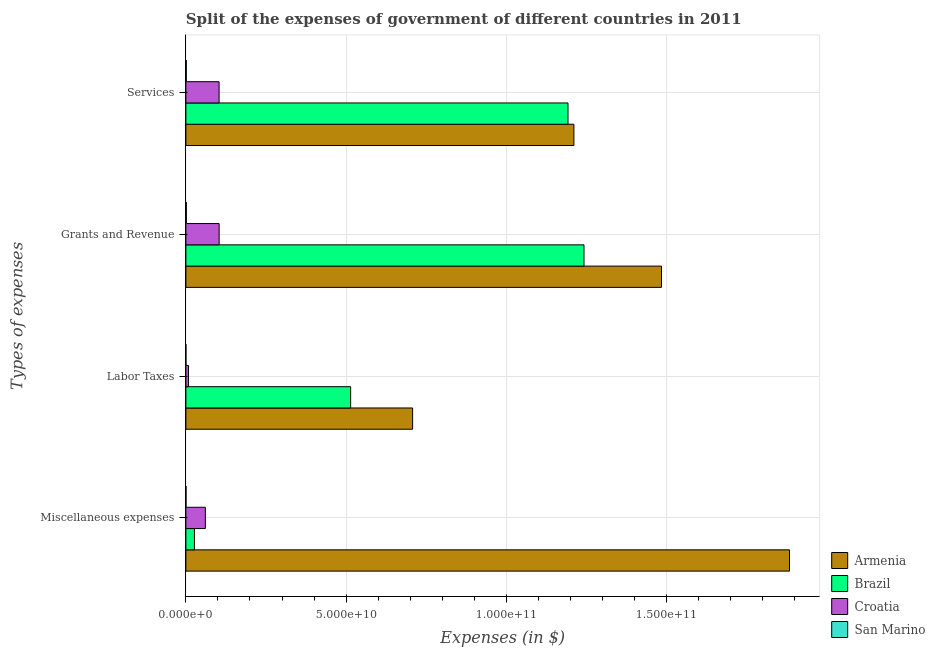Are the number of bars per tick equal to the number of legend labels?
Give a very brief answer. Yes. How many bars are there on the 4th tick from the top?
Your answer should be very brief. 4. What is the label of the 4th group of bars from the top?
Make the answer very short. Miscellaneous expenses. What is the amount spent on grants and revenue in Brazil?
Keep it short and to the point. 1.24e+11. Across all countries, what is the maximum amount spent on labor taxes?
Keep it short and to the point. 7.07e+1. Across all countries, what is the minimum amount spent on grants and revenue?
Offer a very short reply. 1.51e+08. In which country was the amount spent on grants and revenue maximum?
Make the answer very short. Armenia. In which country was the amount spent on labor taxes minimum?
Your answer should be compact. San Marino. What is the total amount spent on services in the graph?
Provide a succinct answer. 2.51e+11. What is the difference between the amount spent on services in Croatia and that in Armenia?
Your answer should be very brief. -1.11e+11. What is the difference between the amount spent on services in San Marino and the amount spent on labor taxes in Armenia?
Offer a terse response. -7.06e+1. What is the average amount spent on grants and revenue per country?
Provide a short and direct response. 7.08e+1. What is the difference between the amount spent on miscellaneous expenses and amount spent on labor taxes in Armenia?
Your answer should be compact. 1.18e+11. In how many countries, is the amount spent on labor taxes greater than 110000000000 $?
Provide a succinct answer. 0. What is the ratio of the amount spent on services in Brazil to that in Croatia?
Your response must be concise. 11.5. Is the difference between the amount spent on services in Armenia and Brazil greater than the difference between the amount spent on miscellaneous expenses in Armenia and Brazil?
Provide a succinct answer. No. What is the difference between the highest and the second highest amount spent on grants and revenue?
Your response must be concise. 2.42e+1. What is the difference between the highest and the lowest amount spent on labor taxes?
Make the answer very short. 7.07e+1. Is the sum of the amount spent on miscellaneous expenses in Brazil and San Marino greater than the maximum amount spent on labor taxes across all countries?
Provide a short and direct response. No. Is it the case that in every country, the sum of the amount spent on labor taxes and amount spent on miscellaneous expenses is greater than the sum of amount spent on grants and revenue and amount spent on services?
Provide a succinct answer. No. What does the 1st bar from the top in Grants and Revenue represents?
Your answer should be very brief. San Marino. What does the 1st bar from the bottom in Services represents?
Ensure brevity in your answer.  Armenia. How many bars are there?
Offer a terse response. 16. What is the difference between two consecutive major ticks on the X-axis?
Offer a terse response. 5.00e+1. Are the values on the major ticks of X-axis written in scientific E-notation?
Offer a terse response. Yes. Does the graph contain grids?
Your response must be concise. Yes. How many legend labels are there?
Offer a very short reply. 4. What is the title of the graph?
Provide a succinct answer. Split of the expenses of government of different countries in 2011. What is the label or title of the X-axis?
Give a very brief answer. Expenses (in $). What is the label or title of the Y-axis?
Offer a very short reply. Types of expenses. What is the Expenses (in $) of Armenia in Miscellaneous expenses?
Provide a succinct answer. 1.88e+11. What is the Expenses (in $) of Brazil in Miscellaneous expenses?
Make the answer very short. 2.67e+09. What is the Expenses (in $) in Croatia in Miscellaneous expenses?
Offer a terse response. 6.08e+09. What is the Expenses (in $) in San Marino in Miscellaneous expenses?
Your answer should be very brief. 3.76e+07. What is the Expenses (in $) in Armenia in Labor Taxes?
Ensure brevity in your answer.  7.07e+1. What is the Expenses (in $) of Brazil in Labor Taxes?
Your answer should be compact. 5.14e+1. What is the Expenses (in $) of Croatia in Labor Taxes?
Your response must be concise. 8.16e+08. What is the Expenses (in $) of San Marino in Labor Taxes?
Give a very brief answer. 1.45e+07. What is the Expenses (in $) in Armenia in Grants and Revenue?
Offer a terse response. 1.48e+11. What is the Expenses (in $) of Brazil in Grants and Revenue?
Your answer should be very brief. 1.24e+11. What is the Expenses (in $) of Croatia in Grants and Revenue?
Offer a terse response. 1.04e+1. What is the Expenses (in $) of San Marino in Grants and Revenue?
Keep it short and to the point. 1.51e+08. What is the Expenses (in $) in Armenia in Services?
Offer a very short reply. 1.21e+11. What is the Expenses (in $) in Brazil in Services?
Your answer should be very brief. 1.19e+11. What is the Expenses (in $) in Croatia in Services?
Ensure brevity in your answer.  1.04e+1. What is the Expenses (in $) of San Marino in Services?
Provide a short and direct response. 1.39e+08. Across all Types of expenses, what is the maximum Expenses (in $) in Armenia?
Ensure brevity in your answer.  1.88e+11. Across all Types of expenses, what is the maximum Expenses (in $) in Brazil?
Provide a short and direct response. 1.24e+11. Across all Types of expenses, what is the maximum Expenses (in $) of Croatia?
Provide a short and direct response. 1.04e+1. Across all Types of expenses, what is the maximum Expenses (in $) of San Marino?
Your answer should be very brief. 1.51e+08. Across all Types of expenses, what is the minimum Expenses (in $) in Armenia?
Keep it short and to the point. 7.07e+1. Across all Types of expenses, what is the minimum Expenses (in $) of Brazil?
Provide a short and direct response. 2.67e+09. Across all Types of expenses, what is the minimum Expenses (in $) in Croatia?
Keep it short and to the point. 8.16e+08. Across all Types of expenses, what is the minimum Expenses (in $) of San Marino?
Ensure brevity in your answer.  1.45e+07. What is the total Expenses (in $) of Armenia in the graph?
Ensure brevity in your answer.  5.28e+11. What is the total Expenses (in $) in Brazil in the graph?
Provide a succinct answer. 2.97e+11. What is the total Expenses (in $) in Croatia in the graph?
Provide a short and direct response. 2.76e+1. What is the total Expenses (in $) in San Marino in the graph?
Provide a short and direct response. 3.43e+08. What is the difference between the Expenses (in $) in Armenia in Miscellaneous expenses and that in Labor Taxes?
Your answer should be compact. 1.18e+11. What is the difference between the Expenses (in $) of Brazil in Miscellaneous expenses and that in Labor Taxes?
Keep it short and to the point. -4.87e+1. What is the difference between the Expenses (in $) of Croatia in Miscellaneous expenses and that in Labor Taxes?
Your answer should be compact. 5.26e+09. What is the difference between the Expenses (in $) in San Marino in Miscellaneous expenses and that in Labor Taxes?
Make the answer very short. 2.31e+07. What is the difference between the Expenses (in $) in Armenia in Miscellaneous expenses and that in Grants and Revenue?
Give a very brief answer. 3.99e+1. What is the difference between the Expenses (in $) in Brazil in Miscellaneous expenses and that in Grants and Revenue?
Give a very brief answer. -1.22e+11. What is the difference between the Expenses (in $) of Croatia in Miscellaneous expenses and that in Grants and Revenue?
Offer a terse response. -4.30e+09. What is the difference between the Expenses (in $) in San Marino in Miscellaneous expenses and that in Grants and Revenue?
Your response must be concise. -1.14e+08. What is the difference between the Expenses (in $) of Armenia in Miscellaneous expenses and that in Services?
Offer a terse response. 6.73e+1. What is the difference between the Expenses (in $) in Brazil in Miscellaneous expenses and that in Services?
Offer a very short reply. -1.17e+11. What is the difference between the Expenses (in $) in Croatia in Miscellaneous expenses and that in Services?
Provide a short and direct response. -4.29e+09. What is the difference between the Expenses (in $) of San Marino in Miscellaneous expenses and that in Services?
Ensure brevity in your answer.  -1.02e+08. What is the difference between the Expenses (in $) of Armenia in Labor Taxes and that in Grants and Revenue?
Offer a terse response. -7.76e+1. What is the difference between the Expenses (in $) of Brazil in Labor Taxes and that in Grants and Revenue?
Your answer should be compact. -7.28e+1. What is the difference between the Expenses (in $) of Croatia in Labor Taxes and that in Grants and Revenue?
Your answer should be very brief. -9.56e+09. What is the difference between the Expenses (in $) of San Marino in Labor Taxes and that in Grants and Revenue?
Your answer should be compact. -1.37e+08. What is the difference between the Expenses (in $) of Armenia in Labor Taxes and that in Services?
Your answer should be very brief. -5.03e+1. What is the difference between the Expenses (in $) of Brazil in Labor Taxes and that in Services?
Give a very brief answer. -6.78e+1. What is the difference between the Expenses (in $) in Croatia in Labor Taxes and that in Services?
Your response must be concise. -9.55e+09. What is the difference between the Expenses (in $) in San Marino in Labor Taxes and that in Services?
Offer a terse response. -1.25e+08. What is the difference between the Expenses (in $) of Armenia in Grants and Revenue and that in Services?
Keep it short and to the point. 2.73e+1. What is the difference between the Expenses (in $) of Brazil in Grants and Revenue and that in Services?
Offer a terse response. 4.99e+09. What is the difference between the Expenses (in $) in Croatia in Grants and Revenue and that in Services?
Give a very brief answer. 1.51e+07. What is the difference between the Expenses (in $) of San Marino in Grants and Revenue and that in Services?
Your answer should be compact. 1.18e+07. What is the difference between the Expenses (in $) in Armenia in Miscellaneous expenses and the Expenses (in $) in Brazil in Labor Taxes?
Your response must be concise. 1.37e+11. What is the difference between the Expenses (in $) of Armenia in Miscellaneous expenses and the Expenses (in $) of Croatia in Labor Taxes?
Offer a very short reply. 1.87e+11. What is the difference between the Expenses (in $) of Armenia in Miscellaneous expenses and the Expenses (in $) of San Marino in Labor Taxes?
Your answer should be compact. 1.88e+11. What is the difference between the Expenses (in $) in Brazil in Miscellaneous expenses and the Expenses (in $) in Croatia in Labor Taxes?
Give a very brief answer. 1.86e+09. What is the difference between the Expenses (in $) of Brazil in Miscellaneous expenses and the Expenses (in $) of San Marino in Labor Taxes?
Provide a succinct answer. 2.66e+09. What is the difference between the Expenses (in $) in Croatia in Miscellaneous expenses and the Expenses (in $) in San Marino in Labor Taxes?
Provide a short and direct response. 6.06e+09. What is the difference between the Expenses (in $) of Armenia in Miscellaneous expenses and the Expenses (in $) of Brazil in Grants and Revenue?
Offer a terse response. 6.41e+1. What is the difference between the Expenses (in $) of Armenia in Miscellaneous expenses and the Expenses (in $) of Croatia in Grants and Revenue?
Your answer should be very brief. 1.78e+11. What is the difference between the Expenses (in $) in Armenia in Miscellaneous expenses and the Expenses (in $) in San Marino in Grants and Revenue?
Your answer should be very brief. 1.88e+11. What is the difference between the Expenses (in $) of Brazil in Miscellaneous expenses and the Expenses (in $) of Croatia in Grants and Revenue?
Provide a succinct answer. -7.71e+09. What is the difference between the Expenses (in $) of Brazil in Miscellaneous expenses and the Expenses (in $) of San Marino in Grants and Revenue?
Offer a terse response. 2.52e+09. What is the difference between the Expenses (in $) in Croatia in Miscellaneous expenses and the Expenses (in $) in San Marino in Grants and Revenue?
Your response must be concise. 5.93e+09. What is the difference between the Expenses (in $) in Armenia in Miscellaneous expenses and the Expenses (in $) in Brazil in Services?
Your response must be concise. 6.91e+1. What is the difference between the Expenses (in $) of Armenia in Miscellaneous expenses and the Expenses (in $) of Croatia in Services?
Make the answer very short. 1.78e+11. What is the difference between the Expenses (in $) of Armenia in Miscellaneous expenses and the Expenses (in $) of San Marino in Services?
Offer a terse response. 1.88e+11. What is the difference between the Expenses (in $) in Brazil in Miscellaneous expenses and the Expenses (in $) in Croatia in Services?
Your answer should be very brief. -7.69e+09. What is the difference between the Expenses (in $) in Brazil in Miscellaneous expenses and the Expenses (in $) in San Marino in Services?
Provide a short and direct response. 2.53e+09. What is the difference between the Expenses (in $) of Croatia in Miscellaneous expenses and the Expenses (in $) of San Marino in Services?
Make the answer very short. 5.94e+09. What is the difference between the Expenses (in $) of Armenia in Labor Taxes and the Expenses (in $) of Brazil in Grants and Revenue?
Your answer should be compact. -5.35e+1. What is the difference between the Expenses (in $) in Armenia in Labor Taxes and the Expenses (in $) in Croatia in Grants and Revenue?
Your answer should be compact. 6.04e+1. What is the difference between the Expenses (in $) in Armenia in Labor Taxes and the Expenses (in $) in San Marino in Grants and Revenue?
Make the answer very short. 7.06e+1. What is the difference between the Expenses (in $) in Brazil in Labor Taxes and the Expenses (in $) in Croatia in Grants and Revenue?
Your answer should be very brief. 4.10e+1. What is the difference between the Expenses (in $) of Brazil in Labor Taxes and the Expenses (in $) of San Marino in Grants and Revenue?
Provide a succinct answer. 5.12e+1. What is the difference between the Expenses (in $) of Croatia in Labor Taxes and the Expenses (in $) of San Marino in Grants and Revenue?
Make the answer very short. 6.65e+08. What is the difference between the Expenses (in $) in Armenia in Labor Taxes and the Expenses (in $) in Brazil in Services?
Offer a very short reply. -4.85e+1. What is the difference between the Expenses (in $) of Armenia in Labor Taxes and the Expenses (in $) of Croatia in Services?
Give a very brief answer. 6.04e+1. What is the difference between the Expenses (in $) in Armenia in Labor Taxes and the Expenses (in $) in San Marino in Services?
Provide a succinct answer. 7.06e+1. What is the difference between the Expenses (in $) in Brazil in Labor Taxes and the Expenses (in $) in Croatia in Services?
Give a very brief answer. 4.10e+1. What is the difference between the Expenses (in $) of Brazil in Labor Taxes and the Expenses (in $) of San Marino in Services?
Keep it short and to the point. 5.13e+1. What is the difference between the Expenses (in $) of Croatia in Labor Taxes and the Expenses (in $) of San Marino in Services?
Your response must be concise. 6.77e+08. What is the difference between the Expenses (in $) in Armenia in Grants and Revenue and the Expenses (in $) in Brazil in Services?
Your answer should be compact. 2.92e+1. What is the difference between the Expenses (in $) of Armenia in Grants and Revenue and the Expenses (in $) of Croatia in Services?
Your response must be concise. 1.38e+11. What is the difference between the Expenses (in $) in Armenia in Grants and Revenue and the Expenses (in $) in San Marino in Services?
Offer a terse response. 1.48e+11. What is the difference between the Expenses (in $) in Brazil in Grants and Revenue and the Expenses (in $) in Croatia in Services?
Make the answer very short. 1.14e+11. What is the difference between the Expenses (in $) of Brazil in Grants and Revenue and the Expenses (in $) of San Marino in Services?
Your response must be concise. 1.24e+11. What is the difference between the Expenses (in $) in Croatia in Grants and Revenue and the Expenses (in $) in San Marino in Services?
Your answer should be very brief. 1.02e+1. What is the average Expenses (in $) of Armenia per Types of expenses?
Ensure brevity in your answer.  1.32e+11. What is the average Expenses (in $) in Brazil per Types of expenses?
Make the answer very short. 7.44e+1. What is the average Expenses (in $) in Croatia per Types of expenses?
Make the answer very short. 6.91e+09. What is the average Expenses (in $) of San Marino per Types of expenses?
Offer a very short reply. 8.57e+07. What is the difference between the Expenses (in $) in Armenia and Expenses (in $) in Brazil in Miscellaneous expenses?
Your response must be concise. 1.86e+11. What is the difference between the Expenses (in $) of Armenia and Expenses (in $) of Croatia in Miscellaneous expenses?
Keep it short and to the point. 1.82e+11. What is the difference between the Expenses (in $) in Armenia and Expenses (in $) in San Marino in Miscellaneous expenses?
Offer a very short reply. 1.88e+11. What is the difference between the Expenses (in $) in Brazil and Expenses (in $) in Croatia in Miscellaneous expenses?
Offer a very short reply. -3.40e+09. What is the difference between the Expenses (in $) of Brazil and Expenses (in $) of San Marino in Miscellaneous expenses?
Give a very brief answer. 2.64e+09. What is the difference between the Expenses (in $) of Croatia and Expenses (in $) of San Marino in Miscellaneous expenses?
Your response must be concise. 6.04e+09. What is the difference between the Expenses (in $) in Armenia and Expenses (in $) in Brazil in Labor Taxes?
Your response must be concise. 1.93e+1. What is the difference between the Expenses (in $) of Armenia and Expenses (in $) of Croatia in Labor Taxes?
Make the answer very short. 6.99e+1. What is the difference between the Expenses (in $) in Armenia and Expenses (in $) in San Marino in Labor Taxes?
Offer a very short reply. 7.07e+1. What is the difference between the Expenses (in $) of Brazil and Expenses (in $) of Croatia in Labor Taxes?
Your answer should be compact. 5.06e+1. What is the difference between the Expenses (in $) of Brazil and Expenses (in $) of San Marino in Labor Taxes?
Make the answer very short. 5.14e+1. What is the difference between the Expenses (in $) of Croatia and Expenses (in $) of San Marino in Labor Taxes?
Provide a succinct answer. 8.02e+08. What is the difference between the Expenses (in $) of Armenia and Expenses (in $) of Brazil in Grants and Revenue?
Ensure brevity in your answer.  2.42e+1. What is the difference between the Expenses (in $) of Armenia and Expenses (in $) of Croatia in Grants and Revenue?
Your answer should be very brief. 1.38e+11. What is the difference between the Expenses (in $) in Armenia and Expenses (in $) in San Marino in Grants and Revenue?
Your response must be concise. 1.48e+11. What is the difference between the Expenses (in $) of Brazil and Expenses (in $) of Croatia in Grants and Revenue?
Keep it short and to the point. 1.14e+11. What is the difference between the Expenses (in $) of Brazil and Expenses (in $) of San Marino in Grants and Revenue?
Offer a terse response. 1.24e+11. What is the difference between the Expenses (in $) in Croatia and Expenses (in $) in San Marino in Grants and Revenue?
Make the answer very short. 1.02e+1. What is the difference between the Expenses (in $) of Armenia and Expenses (in $) of Brazil in Services?
Give a very brief answer. 1.84e+09. What is the difference between the Expenses (in $) of Armenia and Expenses (in $) of Croatia in Services?
Offer a terse response. 1.11e+11. What is the difference between the Expenses (in $) in Armenia and Expenses (in $) in San Marino in Services?
Keep it short and to the point. 1.21e+11. What is the difference between the Expenses (in $) in Brazil and Expenses (in $) in Croatia in Services?
Provide a succinct answer. 1.09e+11. What is the difference between the Expenses (in $) in Brazil and Expenses (in $) in San Marino in Services?
Provide a succinct answer. 1.19e+11. What is the difference between the Expenses (in $) of Croatia and Expenses (in $) of San Marino in Services?
Your answer should be very brief. 1.02e+1. What is the ratio of the Expenses (in $) of Armenia in Miscellaneous expenses to that in Labor Taxes?
Provide a succinct answer. 2.66. What is the ratio of the Expenses (in $) in Brazil in Miscellaneous expenses to that in Labor Taxes?
Keep it short and to the point. 0.05. What is the ratio of the Expenses (in $) in Croatia in Miscellaneous expenses to that in Labor Taxes?
Make the answer very short. 7.45. What is the ratio of the Expenses (in $) in San Marino in Miscellaneous expenses to that in Labor Taxes?
Your response must be concise. 2.59. What is the ratio of the Expenses (in $) of Armenia in Miscellaneous expenses to that in Grants and Revenue?
Your answer should be compact. 1.27. What is the ratio of the Expenses (in $) in Brazil in Miscellaneous expenses to that in Grants and Revenue?
Your response must be concise. 0.02. What is the ratio of the Expenses (in $) in Croatia in Miscellaneous expenses to that in Grants and Revenue?
Your response must be concise. 0.59. What is the ratio of the Expenses (in $) of San Marino in Miscellaneous expenses to that in Grants and Revenue?
Keep it short and to the point. 0.25. What is the ratio of the Expenses (in $) of Armenia in Miscellaneous expenses to that in Services?
Provide a short and direct response. 1.56. What is the ratio of the Expenses (in $) of Brazil in Miscellaneous expenses to that in Services?
Give a very brief answer. 0.02. What is the ratio of the Expenses (in $) in Croatia in Miscellaneous expenses to that in Services?
Ensure brevity in your answer.  0.59. What is the ratio of the Expenses (in $) in San Marino in Miscellaneous expenses to that in Services?
Give a very brief answer. 0.27. What is the ratio of the Expenses (in $) in Armenia in Labor Taxes to that in Grants and Revenue?
Make the answer very short. 0.48. What is the ratio of the Expenses (in $) of Brazil in Labor Taxes to that in Grants and Revenue?
Provide a succinct answer. 0.41. What is the ratio of the Expenses (in $) of Croatia in Labor Taxes to that in Grants and Revenue?
Keep it short and to the point. 0.08. What is the ratio of the Expenses (in $) of San Marino in Labor Taxes to that in Grants and Revenue?
Provide a short and direct response. 0.1. What is the ratio of the Expenses (in $) in Armenia in Labor Taxes to that in Services?
Ensure brevity in your answer.  0.58. What is the ratio of the Expenses (in $) in Brazil in Labor Taxes to that in Services?
Provide a succinct answer. 0.43. What is the ratio of the Expenses (in $) in Croatia in Labor Taxes to that in Services?
Your answer should be compact. 0.08. What is the ratio of the Expenses (in $) in San Marino in Labor Taxes to that in Services?
Provide a succinct answer. 0.1. What is the ratio of the Expenses (in $) of Armenia in Grants and Revenue to that in Services?
Offer a very short reply. 1.23. What is the ratio of the Expenses (in $) of Brazil in Grants and Revenue to that in Services?
Provide a succinct answer. 1.04. What is the ratio of the Expenses (in $) of San Marino in Grants and Revenue to that in Services?
Provide a succinct answer. 1.08. What is the difference between the highest and the second highest Expenses (in $) in Armenia?
Your answer should be very brief. 3.99e+1. What is the difference between the highest and the second highest Expenses (in $) of Brazil?
Your answer should be compact. 4.99e+09. What is the difference between the highest and the second highest Expenses (in $) in Croatia?
Your answer should be very brief. 1.51e+07. What is the difference between the highest and the second highest Expenses (in $) of San Marino?
Offer a terse response. 1.18e+07. What is the difference between the highest and the lowest Expenses (in $) in Armenia?
Provide a short and direct response. 1.18e+11. What is the difference between the highest and the lowest Expenses (in $) of Brazil?
Your answer should be compact. 1.22e+11. What is the difference between the highest and the lowest Expenses (in $) of Croatia?
Your response must be concise. 9.56e+09. What is the difference between the highest and the lowest Expenses (in $) in San Marino?
Make the answer very short. 1.37e+08. 